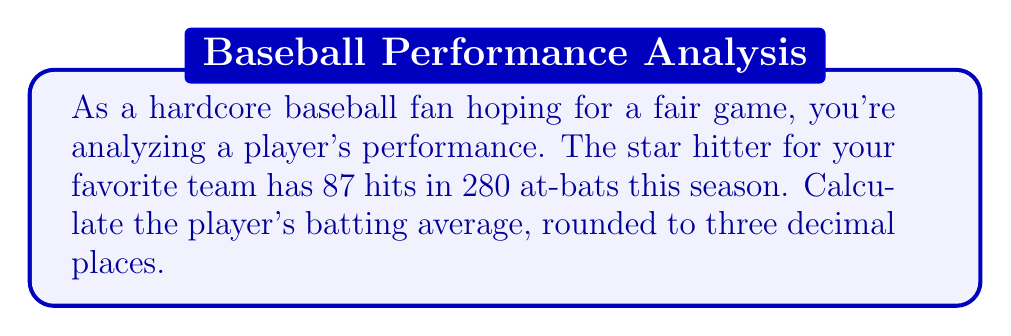Provide a solution to this math problem. To calculate a player's batting average, we use the following formula:

$$ \text{Batting Average} = \frac{\text{Number of Hits}}{\text{Number of At-Bats}} $$

In this case:
- Number of Hits = 87
- Number of At-Bats = 280

Let's substitute these values into the formula:

$$ \text{Batting Average} = \frac{87}{280} $$

To calculate this:

1. Divide 87 by 280:
   $$ \frac{87}{280} = 0.3107142857... $$

2. Round to three decimal places:
   $$ 0.311 $$

Therefore, the player's batting average is 0.311 or .311 in baseball notation.
Answer: 0.311 